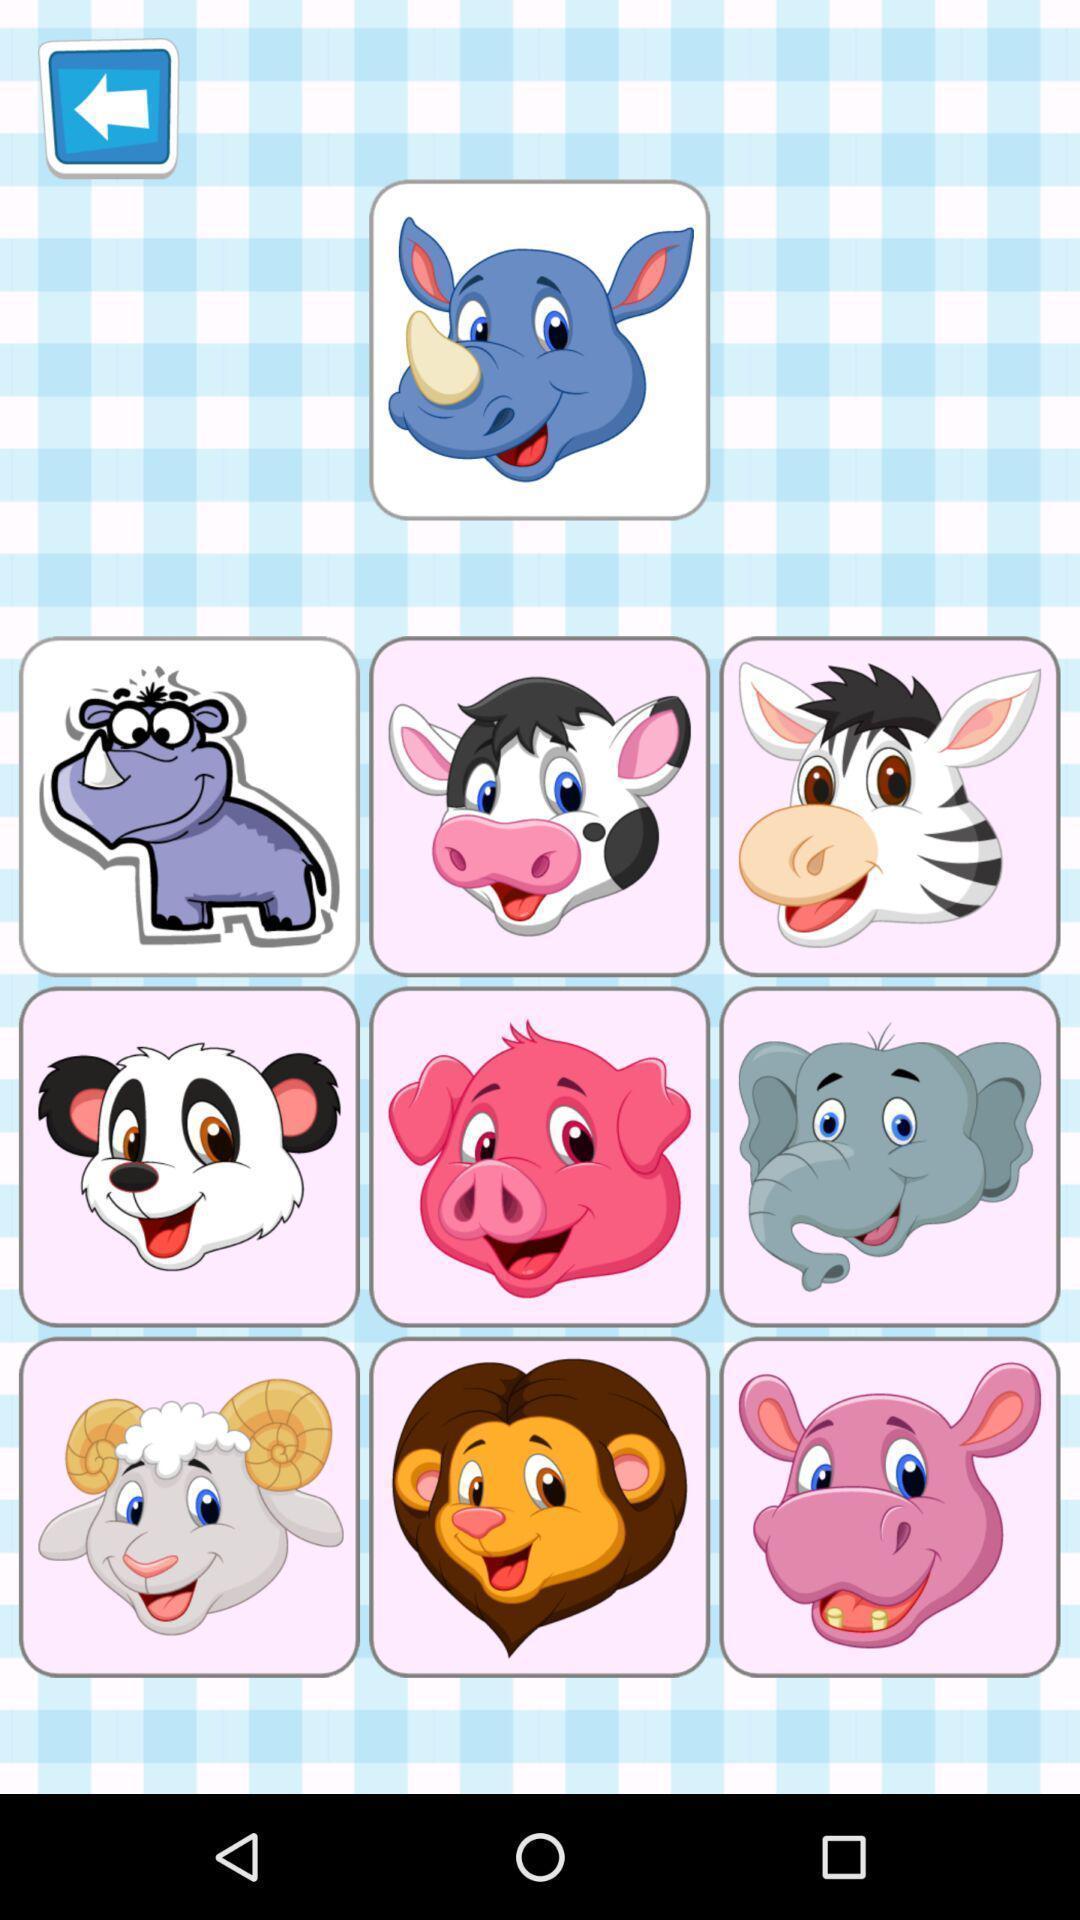Summarize the main components in this picture. Screen displaying multiple animated icons. 